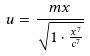<formula> <loc_0><loc_0><loc_500><loc_500>u = \frac { m x } { \sqrt { 1 \cdot \frac { x ^ { 7 } } { c ^ { 7 } } } }</formula> 